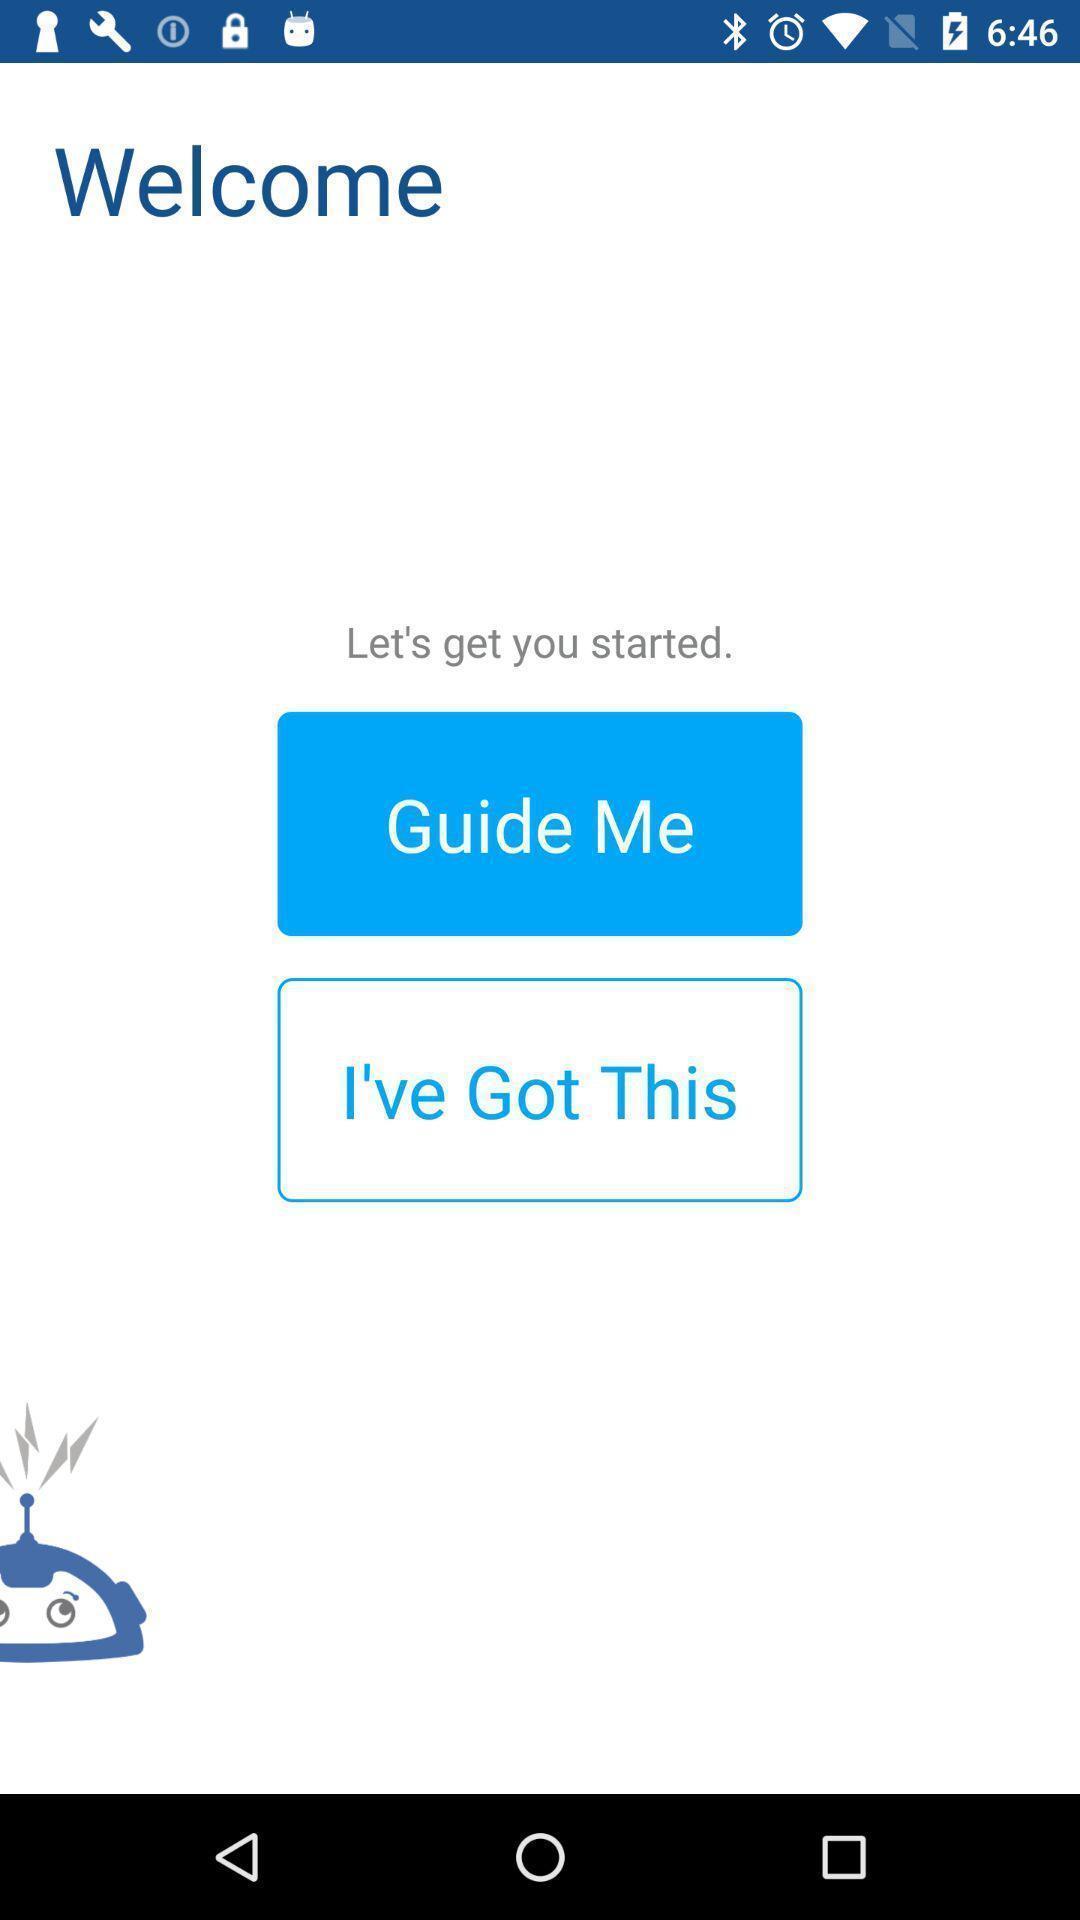What details can you identify in this image? Welcome page the mileage tracking app. 